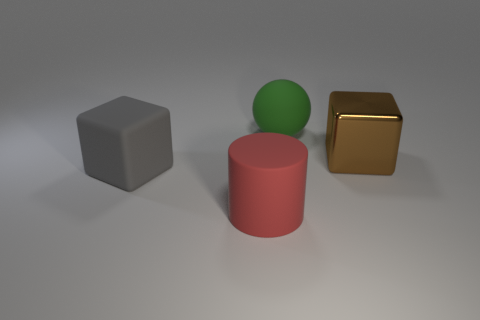What is the color of the other large thing that is the same shape as the gray object?
Provide a succinct answer. Brown. Are there any other things that are the same shape as the metal object?
Ensure brevity in your answer.  Yes. What is the shape of the matte object to the right of the red cylinder?
Provide a succinct answer. Sphere. How many other green things have the same shape as the big green object?
Your answer should be very brief. 0. How many things are blue rubber blocks or large matte objects?
Make the answer very short. 3. What number of gray things have the same material as the red cylinder?
Give a very brief answer. 1. Is the number of red cylinders less than the number of large red metallic objects?
Make the answer very short. No. Does the big cube behind the gray cube have the same material as the cylinder?
Ensure brevity in your answer.  No. How many cylinders are tiny cyan rubber objects or large metallic things?
Offer a very short reply. 0. What is the shape of the large rubber object that is both behind the rubber cylinder and on the right side of the gray object?
Your answer should be compact. Sphere. 